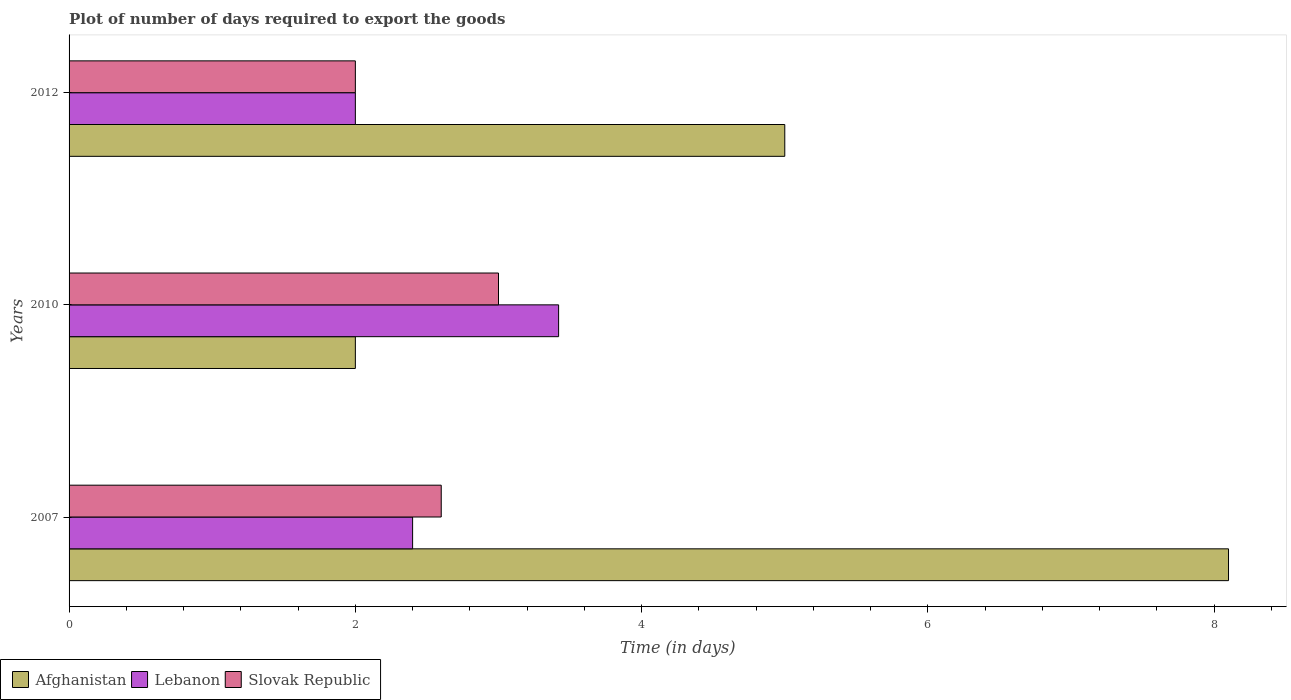Are the number of bars per tick equal to the number of legend labels?
Your answer should be compact. Yes. In how many cases, is the number of bars for a given year not equal to the number of legend labels?
Make the answer very short. 0. What is the time required to export goods in Slovak Republic in 2007?
Keep it short and to the point. 2.6. Across all years, what is the maximum time required to export goods in Lebanon?
Make the answer very short. 3.42. What is the total time required to export goods in Lebanon in the graph?
Your answer should be compact. 7.82. What is the difference between the time required to export goods in Slovak Republic in 2007 and the time required to export goods in Lebanon in 2012?
Your response must be concise. 0.6. What is the average time required to export goods in Slovak Republic per year?
Offer a very short reply. 2.53. In the year 2007, what is the difference between the time required to export goods in Lebanon and time required to export goods in Afghanistan?
Give a very brief answer. -5.7. What is the ratio of the time required to export goods in Afghanistan in 2007 to that in 2012?
Give a very brief answer. 1.62. Is the time required to export goods in Slovak Republic in 2007 less than that in 2012?
Provide a succinct answer. No. What is the difference between the highest and the second highest time required to export goods in Afghanistan?
Offer a very short reply. 3.1. Is the sum of the time required to export goods in Afghanistan in 2010 and 2012 greater than the maximum time required to export goods in Slovak Republic across all years?
Your answer should be very brief. Yes. What does the 2nd bar from the top in 2010 represents?
Your answer should be compact. Lebanon. What does the 1st bar from the bottom in 2010 represents?
Give a very brief answer. Afghanistan. Is it the case that in every year, the sum of the time required to export goods in Afghanistan and time required to export goods in Slovak Republic is greater than the time required to export goods in Lebanon?
Your response must be concise. Yes. How many bars are there?
Keep it short and to the point. 9. How many years are there in the graph?
Your answer should be very brief. 3. Does the graph contain any zero values?
Make the answer very short. No. What is the title of the graph?
Offer a very short reply. Plot of number of days required to export the goods. Does "Malaysia" appear as one of the legend labels in the graph?
Your answer should be compact. No. What is the label or title of the X-axis?
Make the answer very short. Time (in days). What is the label or title of the Y-axis?
Provide a succinct answer. Years. What is the Time (in days) in Lebanon in 2007?
Keep it short and to the point. 2.4. What is the Time (in days) of Afghanistan in 2010?
Provide a short and direct response. 2. What is the Time (in days) of Lebanon in 2010?
Keep it short and to the point. 3.42. Across all years, what is the maximum Time (in days) in Lebanon?
Offer a terse response. 3.42. Across all years, what is the minimum Time (in days) in Slovak Republic?
Your answer should be compact. 2. What is the total Time (in days) of Lebanon in the graph?
Your answer should be compact. 7.82. What is the difference between the Time (in days) of Lebanon in 2007 and that in 2010?
Offer a very short reply. -1.02. What is the difference between the Time (in days) of Lebanon in 2007 and that in 2012?
Give a very brief answer. 0.4. What is the difference between the Time (in days) in Lebanon in 2010 and that in 2012?
Offer a terse response. 1.42. What is the difference between the Time (in days) in Afghanistan in 2007 and the Time (in days) in Lebanon in 2010?
Provide a short and direct response. 4.68. What is the difference between the Time (in days) of Lebanon in 2007 and the Time (in days) of Slovak Republic in 2010?
Give a very brief answer. -0.6. What is the difference between the Time (in days) in Lebanon in 2010 and the Time (in days) in Slovak Republic in 2012?
Your answer should be compact. 1.42. What is the average Time (in days) in Afghanistan per year?
Your answer should be very brief. 5.03. What is the average Time (in days) of Lebanon per year?
Give a very brief answer. 2.61. What is the average Time (in days) of Slovak Republic per year?
Make the answer very short. 2.53. In the year 2007, what is the difference between the Time (in days) in Afghanistan and Time (in days) in Lebanon?
Provide a succinct answer. 5.7. In the year 2010, what is the difference between the Time (in days) in Afghanistan and Time (in days) in Lebanon?
Your response must be concise. -1.42. In the year 2010, what is the difference between the Time (in days) in Afghanistan and Time (in days) in Slovak Republic?
Make the answer very short. -1. In the year 2010, what is the difference between the Time (in days) of Lebanon and Time (in days) of Slovak Republic?
Keep it short and to the point. 0.42. In the year 2012, what is the difference between the Time (in days) of Afghanistan and Time (in days) of Lebanon?
Keep it short and to the point. 3. What is the ratio of the Time (in days) in Afghanistan in 2007 to that in 2010?
Offer a very short reply. 4.05. What is the ratio of the Time (in days) of Lebanon in 2007 to that in 2010?
Give a very brief answer. 0.7. What is the ratio of the Time (in days) in Slovak Republic in 2007 to that in 2010?
Offer a terse response. 0.87. What is the ratio of the Time (in days) of Afghanistan in 2007 to that in 2012?
Give a very brief answer. 1.62. What is the ratio of the Time (in days) in Slovak Republic in 2007 to that in 2012?
Give a very brief answer. 1.3. What is the ratio of the Time (in days) in Afghanistan in 2010 to that in 2012?
Offer a terse response. 0.4. What is the ratio of the Time (in days) in Lebanon in 2010 to that in 2012?
Offer a very short reply. 1.71. What is the difference between the highest and the second highest Time (in days) in Lebanon?
Keep it short and to the point. 1.02. What is the difference between the highest and the lowest Time (in days) of Lebanon?
Offer a very short reply. 1.42. 